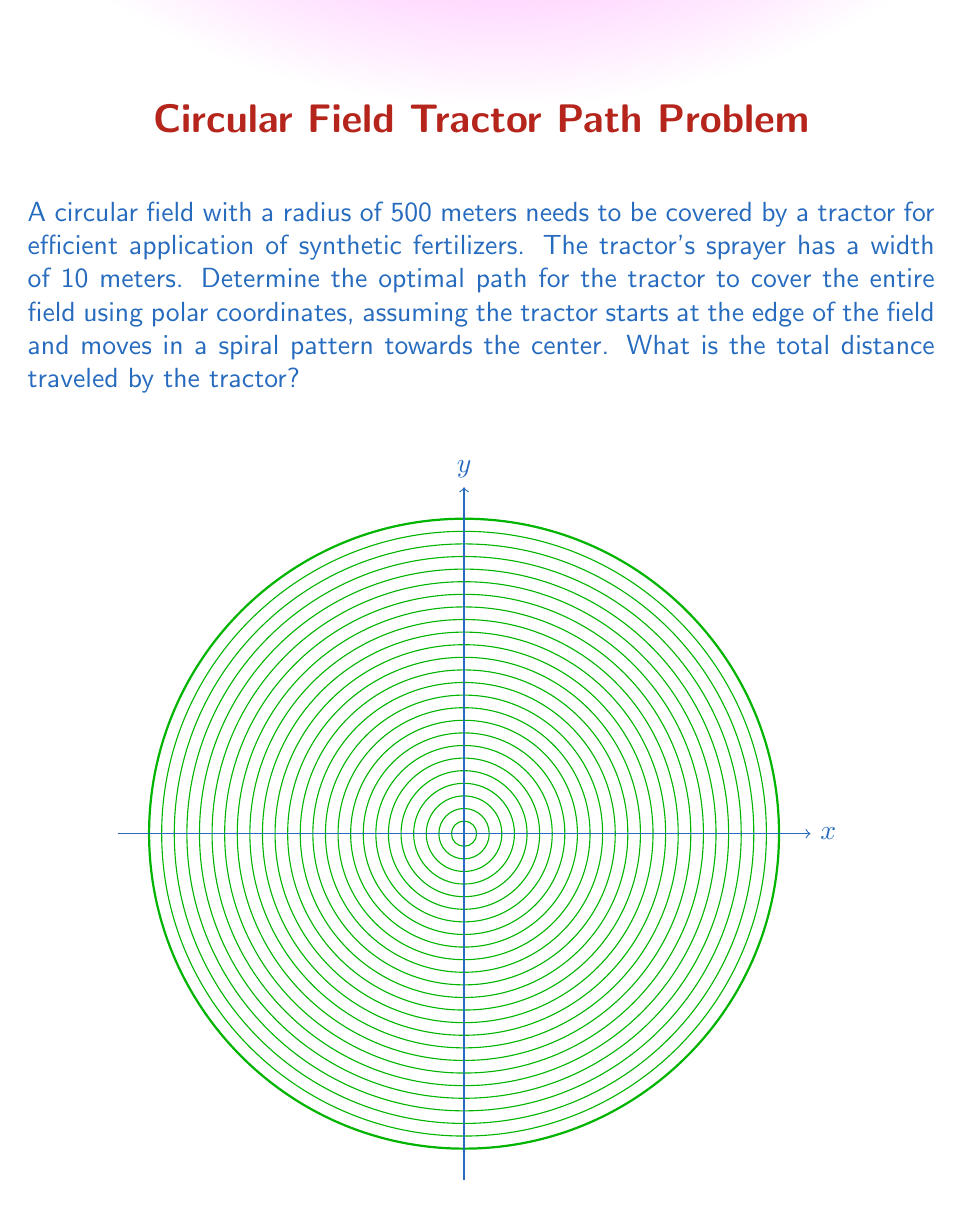Can you solve this math problem? Let's approach this step-by-step:

1) In polar coordinates, we can describe the tractor's path as $r = R - k\theta$, where $R$ is the initial radius and $k$ is a constant that determines how quickly the spiral tightens.

2) We need to find $k$. After one complete revolution (2π radians), the radius should decrease by the width of the sprayer (10 meters):

   $R - k(2\pi) = R - 10$
   $k = \frac{10}{2\pi} = \frac{5}{\pi}$

3) The equation of the spiral is thus:

   $r = 500 - \frac{5}{\pi}\theta$

4) The tractor will stop when $r = 0$:

   $0 = 500 - \frac{5}{\pi}\theta$
   $\theta_{max} = 100\pi$

5) To find the length of the spiral, we use the arc length formula in polar coordinates:

   $L = \int_0^{\theta_{max}} \sqrt{r^2 + (\frac{dr}{d\theta})^2} d\theta$

6) Here, $r = 500 - \frac{5}{\pi}\theta$ and $\frac{dr}{d\theta} = -\frac{5}{\pi}$

7) Substituting into the formula:

   $L = \int_0^{100\pi} \sqrt{(500 - \frac{5}{\pi}\theta)^2 + (\frac{5}{\pi})^2} d\theta$

8) This integral is complex and typically solved numerically. Using numerical integration methods, we get:

   $L \approx 79,577.47$ meters
Answer: $79,577.47$ meters 